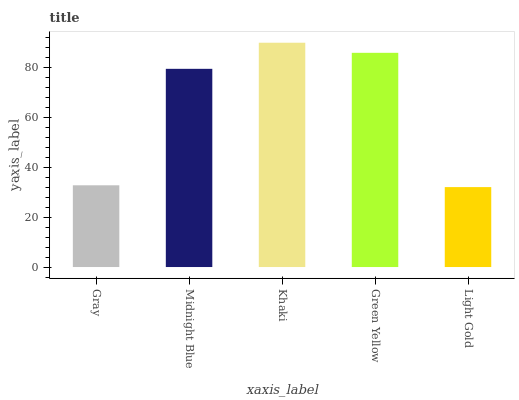Is Light Gold the minimum?
Answer yes or no. Yes. Is Khaki the maximum?
Answer yes or no. Yes. Is Midnight Blue the minimum?
Answer yes or no. No. Is Midnight Blue the maximum?
Answer yes or no. No. Is Midnight Blue greater than Gray?
Answer yes or no. Yes. Is Gray less than Midnight Blue?
Answer yes or no. Yes. Is Gray greater than Midnight Blue?
Answer yes or no. No. Is Midnight Blue less than Gray?
Answer yes or no. No. Is Midnight Blue the high median?
Answer yes or no. Yes. Is Midnight Blue the low median?
Answer yes or no. Yes. Is Khaki the high median?
Answer yes or no. No. Is Green Yellow the low median?
Answer yes or no. No. 